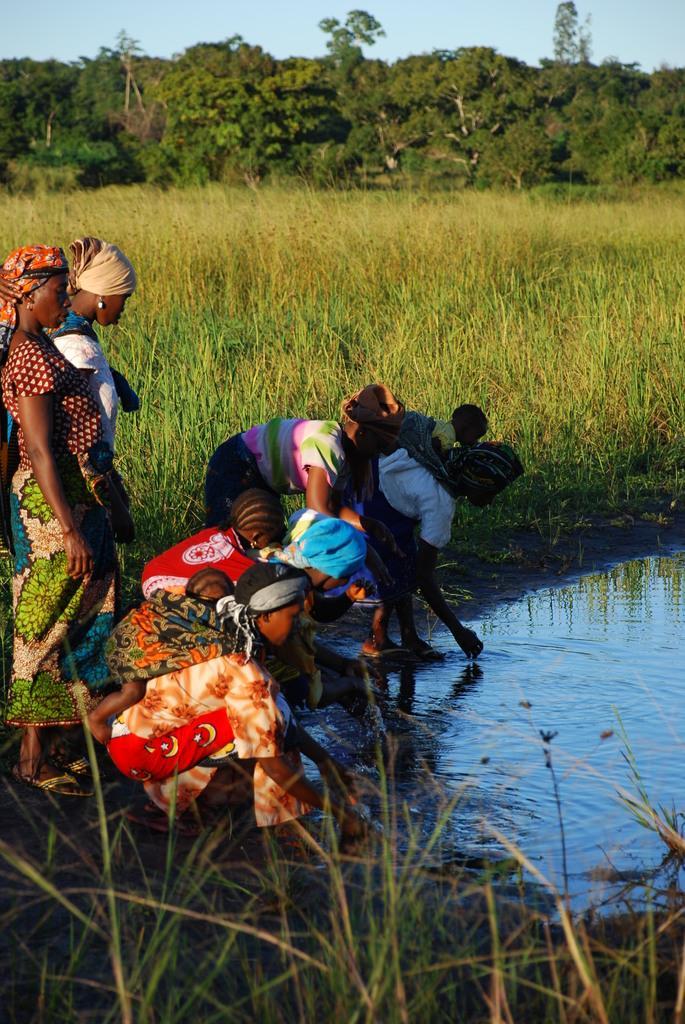How would you summarize this image in a sentence or two? In this image there is the sky towards the top of the image, there are trees, there is grass, there is water towards the right of the image, there are group of women towards the left of the image. 